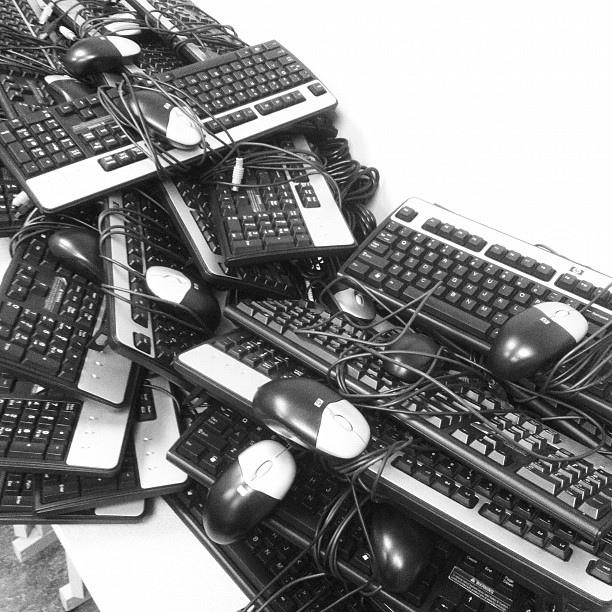Which one of these items would pair well with the items in the photo?

Choices:
A) monitor
B) clock
C) fireplace
D) pillow monitor 